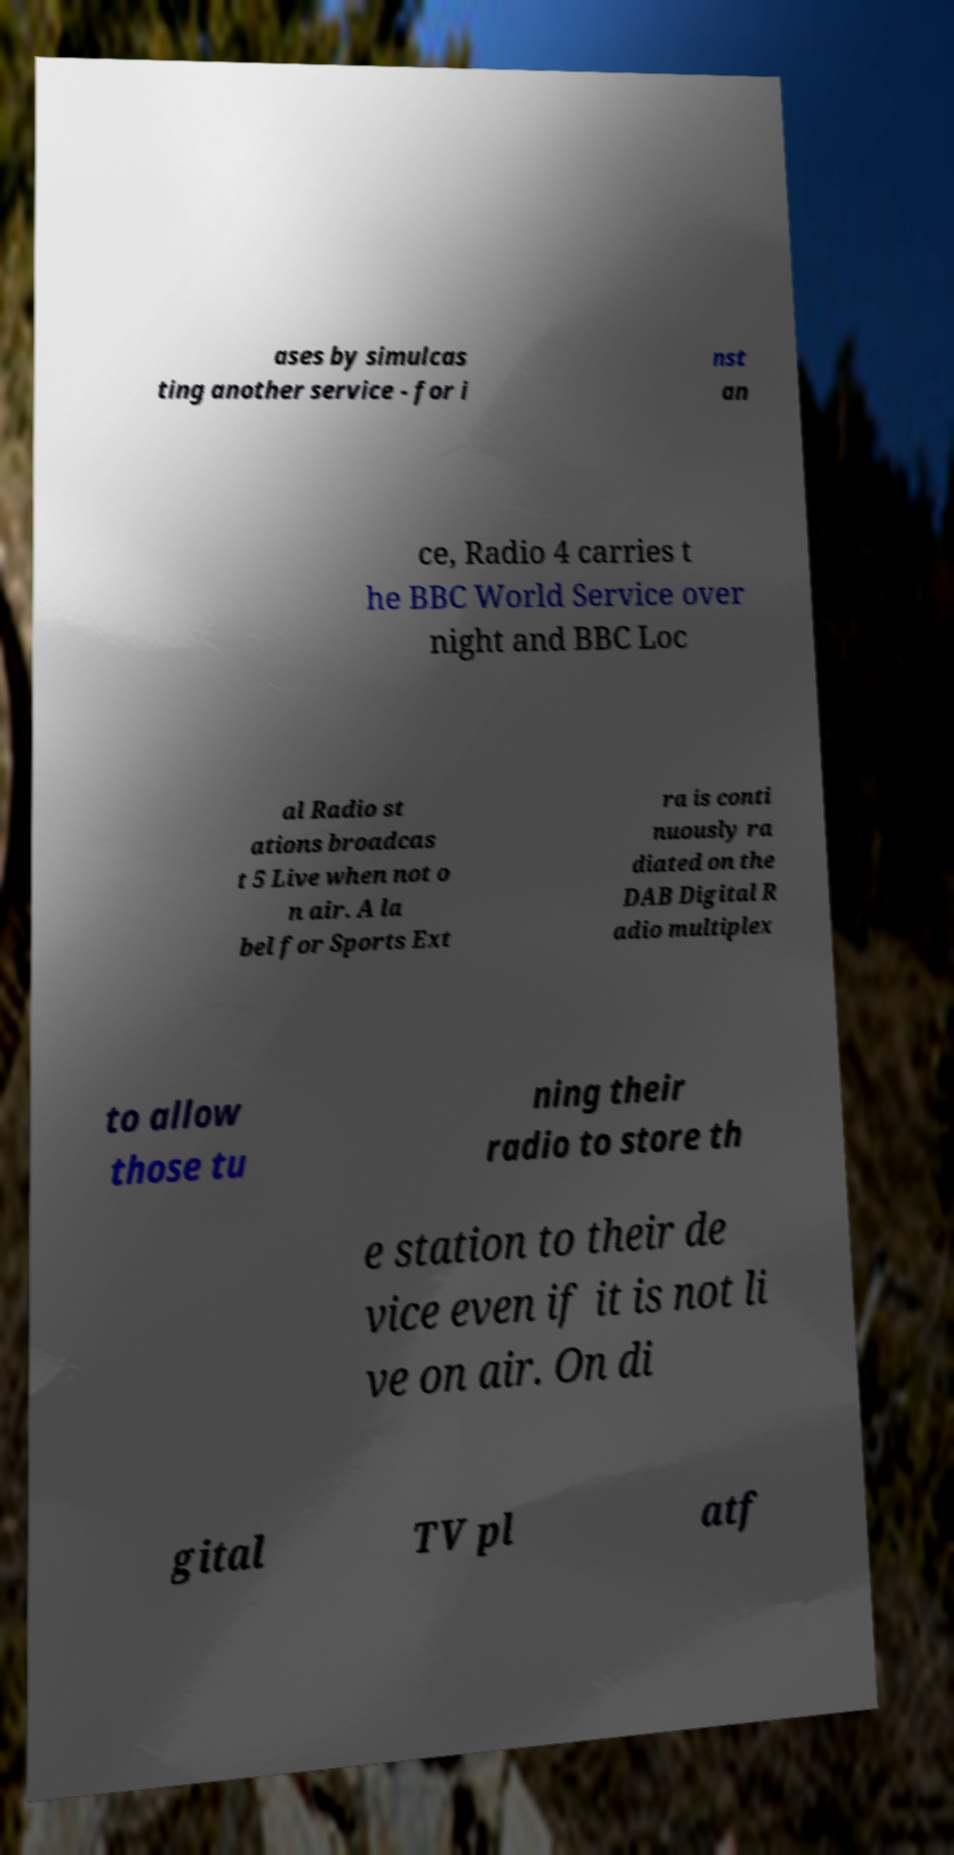I need the written content from this picture converted into text. Can you do that? ases by simulcas ting another service - for i nst an ce, Radio 4 carries t he BBC World Service over night and BBC Loc al Radio st ations broadcas t 5 Live when not o n air. A la bel for Sports Ext ra is conti nuously ra diated on the DAB Digital R adio multiplex to allow those tu ning their radio to store th e station to their de vice even if it is not li ve on air. On di gital TV pl atf 